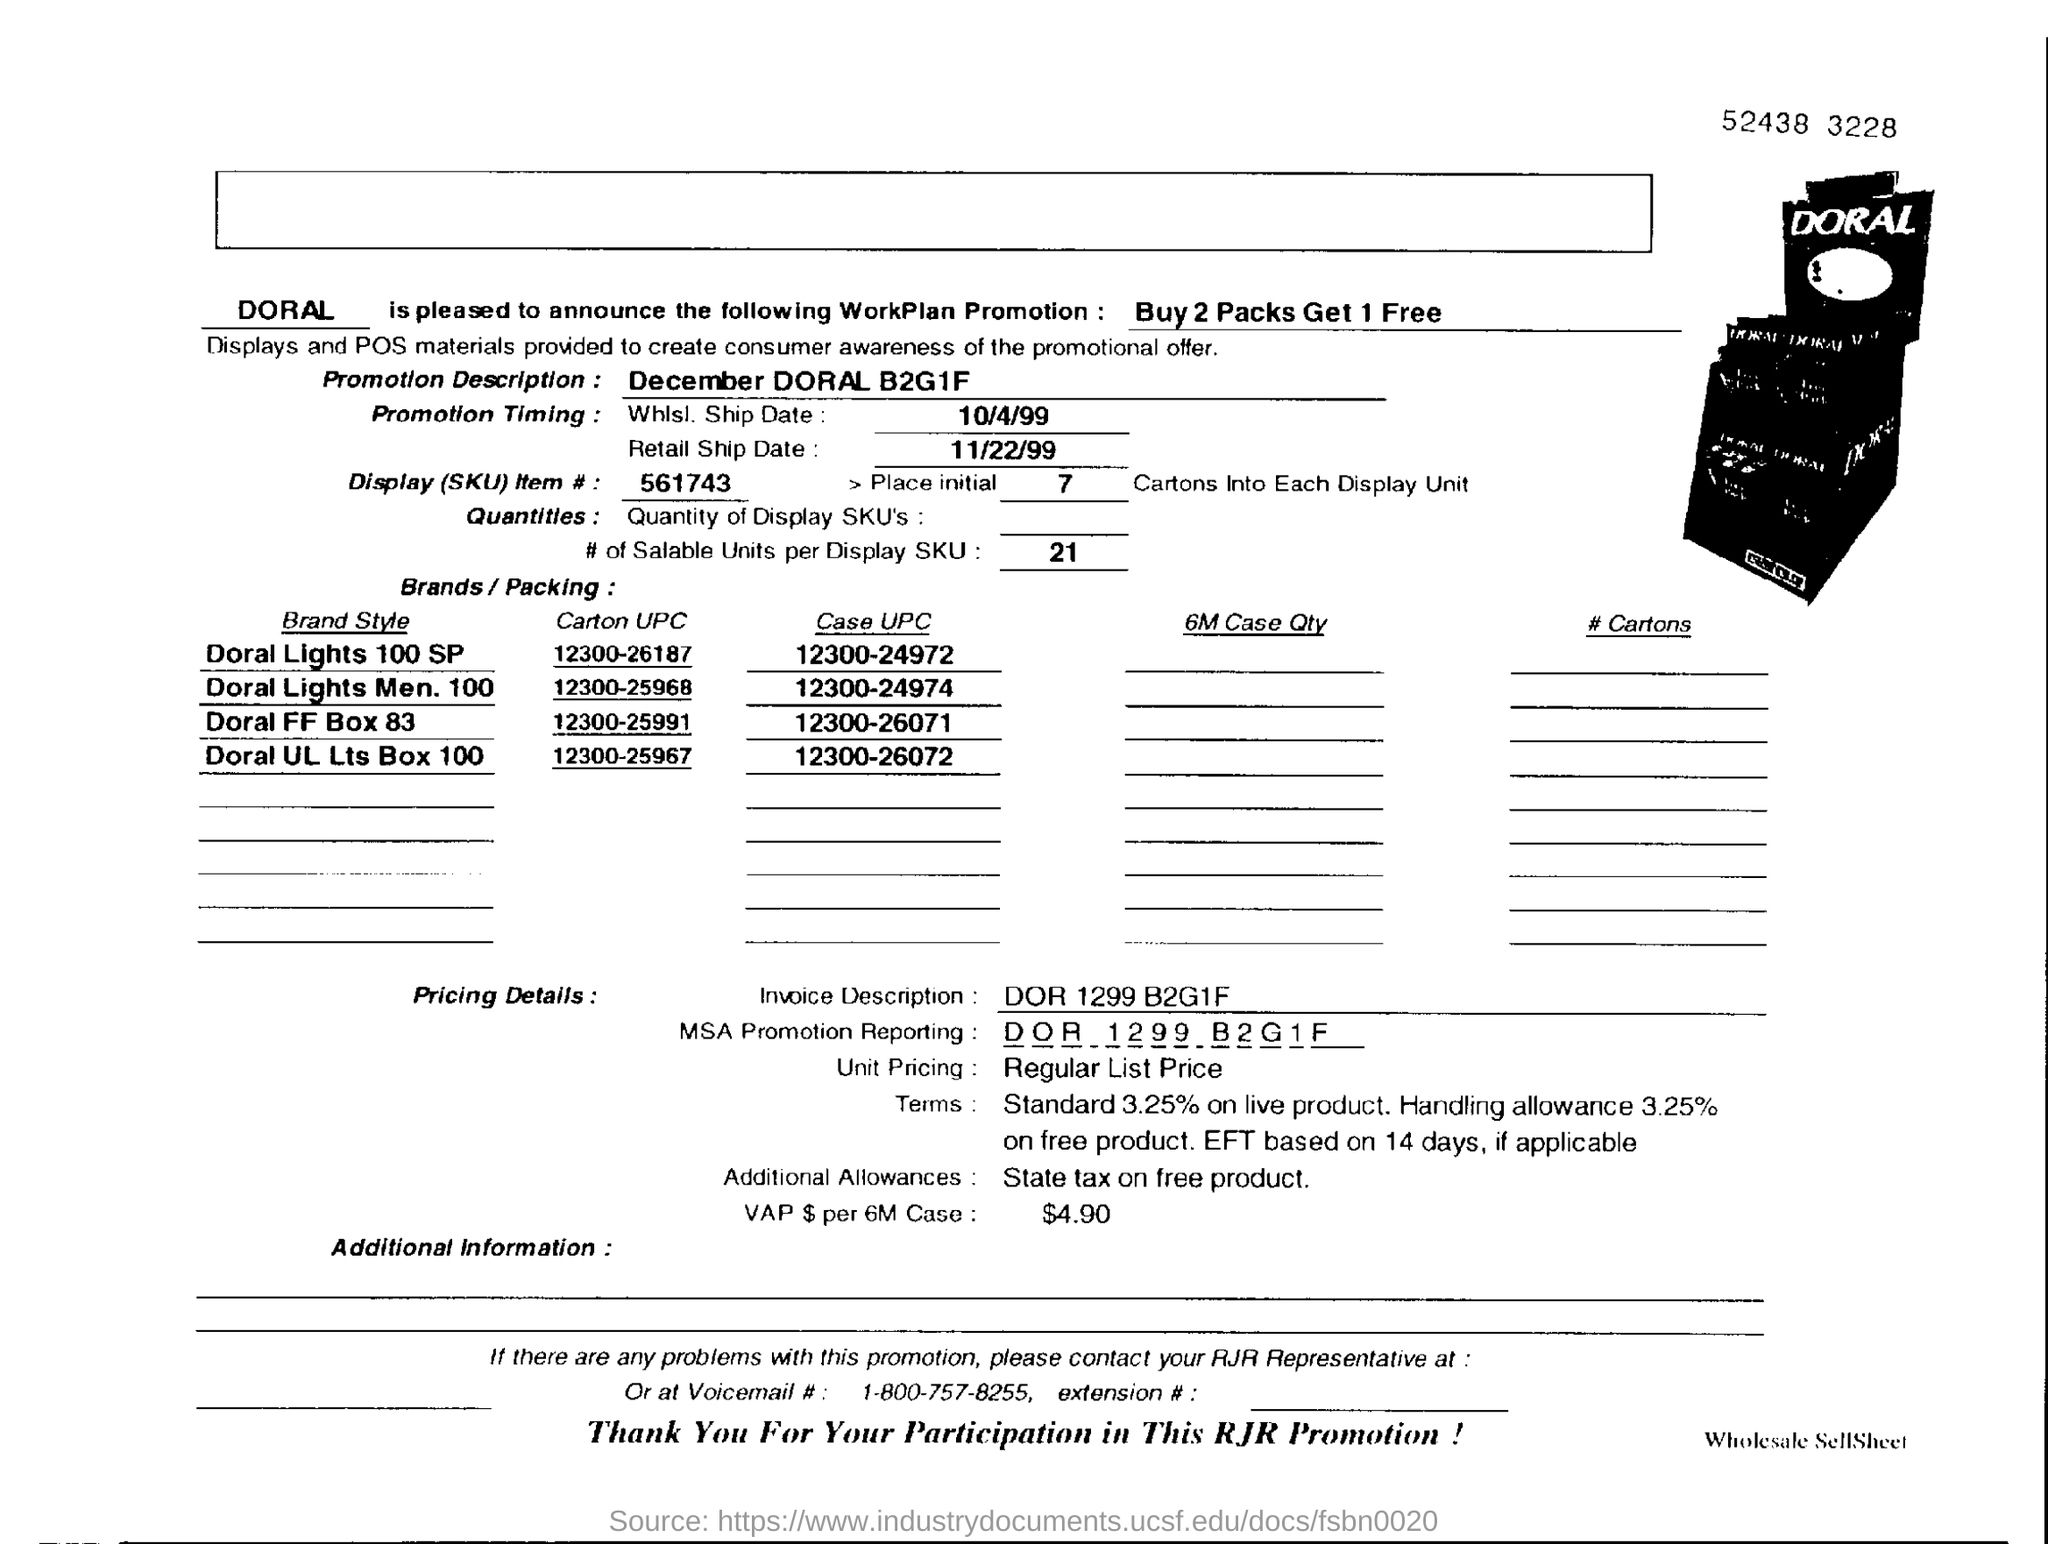What Workplan Promotion has been announced by DORAL?
Provide a short and direct response. Buy 2 packs get 1 free. What is the promotion description?
Keep it short and to the point. December DORAL B2G1F. When is the retail ship date?
Keep it short and to the point. 11/22/99. What is the Display(SKU) Item number?
Provide a succinct answer. 561743. What is the Carton UPC of Doral FF Box 83?
Your answer should be compact. 12300-25991. What is the Invoice Description?
Keep it short and to the point. DOR 1299 B2G1F. What additional allowances are mentioned?
Offer a terse response. State tax on free product. What is VAP $ per 6M Case?
Keep it short and to the point. $4.90. 